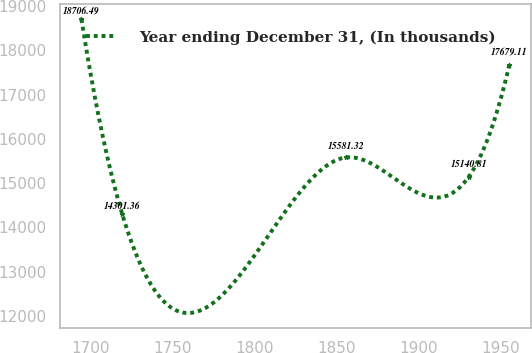Convert chart. <chart><loc_0><loc_0><loc_500><loc_500><line_chart><ecel><fcel>Year ending December 31, (In thousands)<nl><fcel>1694.18<fcel>18706.5<nl><fcel>1719.06<fcel>14301.4<nl><fcel>1855.77<fcel>15581.3<nl><fcel>1930.48<fcel>15140.8<nl><fcel>1955.36<fcel>17679.1<nl></chart> 